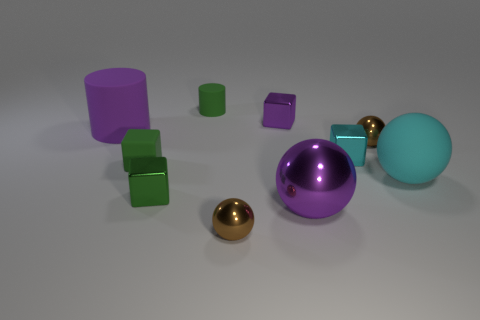Is the number of purple matte things in front of the cyan matte ball greater than the number of green shiny things on the left side of the tiny purple thing?
Make the answer very short. No. What number of green blocks have the same material as the small cylinder?
Keep it short and to the point. 1. Do the cyan shiny thing and the purple matte thing have the same size?
Offer a very short reply. No. What is the color of the small rubber cylinder?
Offer a very short reply. Green. What number of things are either purple rubber objects or big metallic things?
Provide a short and direct response. 2. Is there a cyan metallic thing of the same shape as the tiny green shiny thing?
Provide a short and direct response. Yes. There is a big sphere to the left of the large cyan sphere; is it the same color as the big rubber cylinder?
Offer a very short reply. Yes. There is a tiny brown metal object that is left of the small metal ball behind the small cyan metallic block; what is its shape?
Provide a short and direct response. Sphere. Is there a green matte block that has the same size as the purple block?
Provide a succinct answer. Yes. Is the number of purple matte objects less than the number of matte things?
Make the answer very short. Yes. 